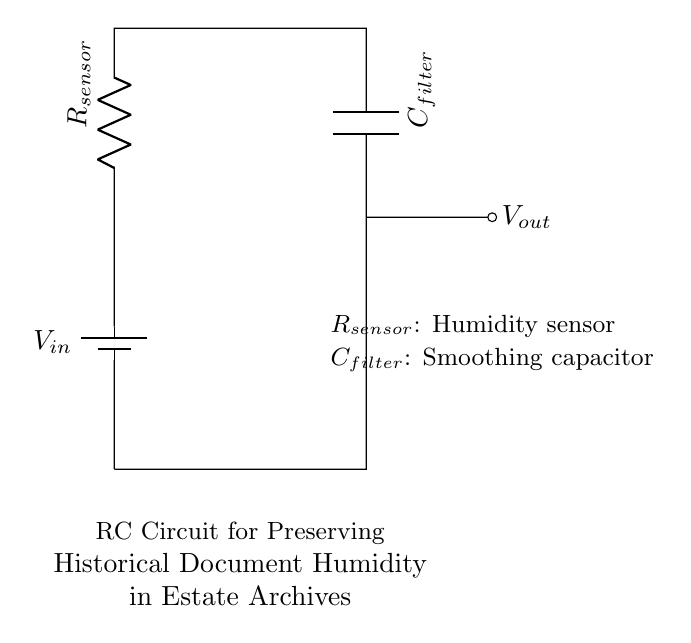What is the voltage source in this circuit? The voltage source is labeled as V_in in the circuit diagram, which represents the power supply driving the circuit.
Answer: V_in What type of sensor is represented in this circuit? The component labeled R_sensor indicates that it is a humidity sensor used to detect moisture levels, critical for preserving documents.
Answer: Humidity sensor What is the purpose of the capacitor in this circuit? The capacitor labeled C_filter is used to smooth or filter the voltage signal coming from the humidity sensor, stabilizing the output voltage.
Answer: Smoothing What is the relationship between the resistor and the capacitor in an RC circuit? The resistor and capacitor work together to create a time constant that determines how quickly the circuit responds to changes in humidity, affecting the overall dynamics of the circuit's output.
Answer: Time constant What does V_out represent? V_out represents the output voltage from the circuit, which is the filtered signal that indicates humidity levels and is critical for data monitoring for document preservation.
Answer: Output voltage How does increasing R_sensor affect the circuit? Increasing R_sensor would typically cause a slower response to changes in humidity, affecting the time constant and potentially delaying the output voltage change, which could be detrimental for timely archival decisions.
Answer: Slower response 